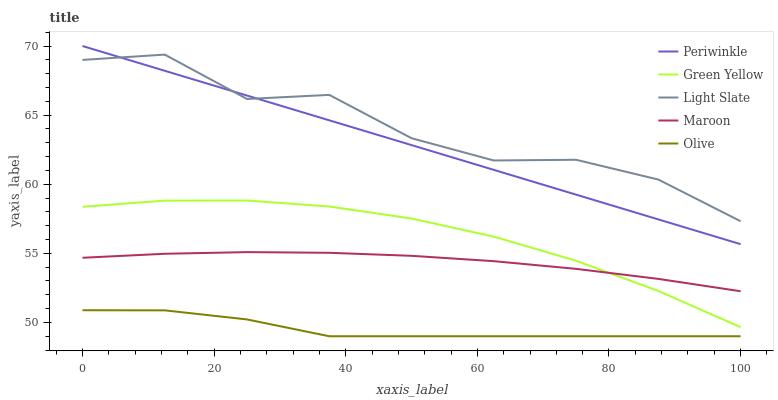Does Olive have the minimum area under the curve?
Answer yes or no. Yes. Does Light Slate have the maximum area under the curve?
Answer yes or no. Yes. Does Green Yellow have the minimum area under the curve?
Answer yes or no. No. Does Green Yellow have the maximum area under the curve?
Answer yes or no. No. Is Periwinkle the smoothest?
Answer yes or no. Yes. Is Light Slate the roughest?
Answer yes or no. Yes. Is Olive the smoothest?
Answer yes or no. No. Is Olive the roughest?
Answer yes or no. No. Does Green Yellow have the lowest value?
Answer yes or no. No. Does Green Yellow have the highest value?
Answer yes or no. No. Is Olive less than Green Yellow?
Answer yes or no. Yes. Is Maroon greater than Olive?
Answer yes or no. Yes. Does Olive intersect Green Yellow?
Answer yes or no. No. 